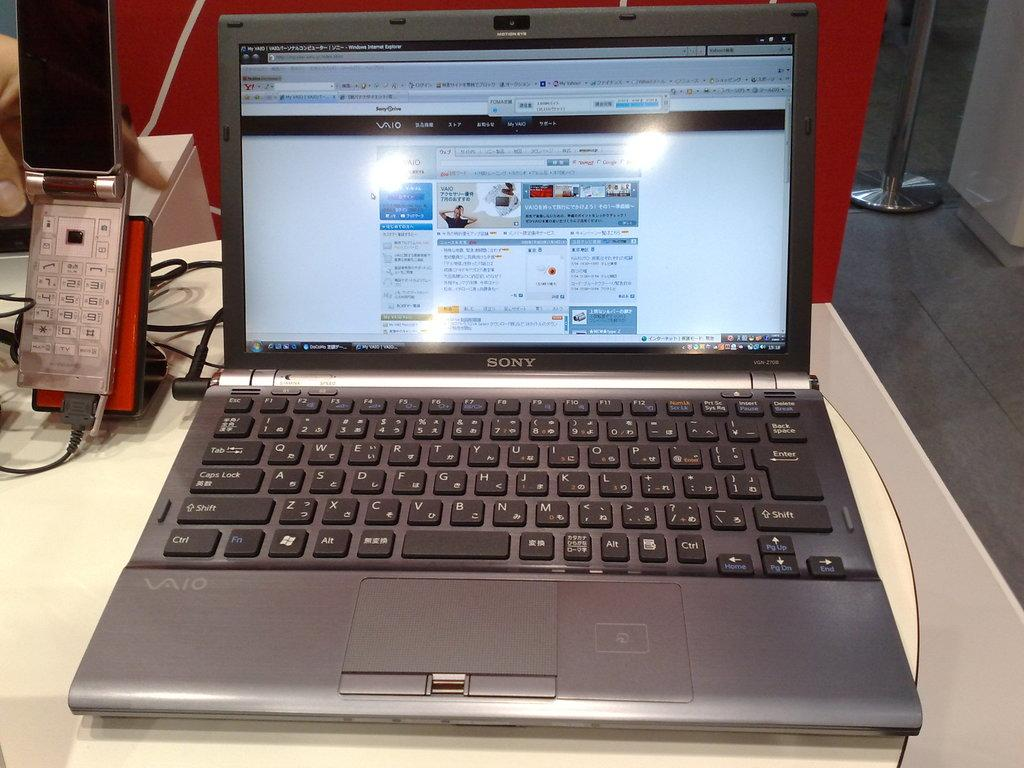<image>
Provide a brief description of the given image. A Sony Laptop open and on on top of a table with an open flip phone next to it. 